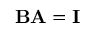<formula> <loc_0><loc_0><loc_500><loc_500>B A = I</formula> 